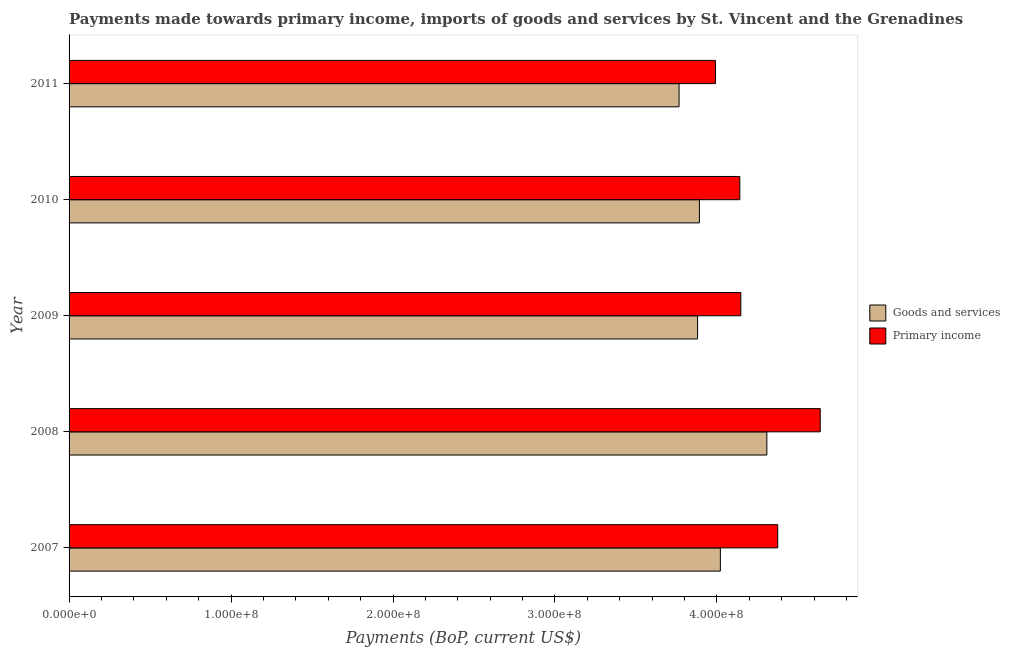How many different coloured bars are there?
Your response must be concise. 2. How many groups of bars are there?
Give a very brief answer. 5. Are the number of bars on each tick of the Y-axis equal?
Offer a very short reply. Yes. How many bars are there on the 5th tick from the top?
Make the answer very short. 2. How many bars are there on the 1st tick from the bottom?
Offer a very short reply. 2. What is the payments made towards goods and services in 2011?
Ensure brevity in your answer.  3.77e+08. Across all years, what is the maximum payments made towards primary income?
Your answer should be compact. 4.64e+08. Across all years, what is the minimum payments made towards primary income?
Your response must be concise. 3.99e+08. In which year was the payments made towards primary income maximum?
Give a very brief answer. 2008. In which year was the payments made towards primary income minimum?
Ensure brevity in your answer.  2011. What is the total payments made towards goods and services in the graph?
Your answer should be very brief. 1.99e+09. What is the difference between the payments made towards primary income in 2007 and that in 2008?
Your answer should be compact. -2.62e+07. What is the difference between the payments made towards primary income in 2011 and the payments made towards goods and services in 2007?
Give a very brief answer. -3.03e+06. What is the average payments made towards goods and services per year?
Your answer should be compact. 3.97e+08. In the year 2011, what is the difference between the payments made towards primary income and payments made towards goods and services?
Your response must be concise. 2.25e+07. What is the ratio of the payments made towards primary income in 2008 to that in 2010?
Offer a terse response. 1.12. What is the difference between the highest and the second highest payments made towards primary income?
Your answer should be very brief. 2.62e+07. What is the difference between the highest and the lowest payments made towards primary income?
Offer a terse response. 6.47e+07. In how many years, is the payments made towards primary income greater than the average payments made towards primary income taken over all years?
Give a very brief answer. 2. Is the sum of the payments made towards primary income in 2007 and 2009 greater than the maximum payments made towards goods and services across all years?
Your answer should be compact. Yes. What does the 1st bar from the top in 2007 represents?
Your answer should be very brief. Primary income. What does the 1st bar from the bottom in 2010 represents?
Offer a very short reply. Goods and services. Are all the bars in the graph horizontal?
Keep it short and to the point. Yes. Does the graph contain grids?
Keep it short and to the point. No. Where does the legend appear in the graph?
Your answer should be very brief. Center right. How are the legend labels stacked?
Make the answer very short. Vertical. What is the title of the graph?
Your response must be concise. Payments made towards primary income, imports of goods and services by St. Vincent and the Grenadines. What is the label or title of the X-axis?
Ensure brevity in your answer.  Payments (BoP, current US$). What is the Payments (BoP, current US$) of Goods and services in 2007?
Give a very brief answer. 4.02e+08. What is the Payments (BoP, current US$) in Primary income in 2007?
Keep it short and to the point. 4.38e+08. What is the Payments (BoP, current US$) of Goods and services in 2008?
Provide a succinct answer. 4.31e+08. What is the Payments (BoP, current US$) in Primary income in 2008?
Ensure brevity in your answer.  4.64e+08. What is the Payments (BoP, current US$) of Goods and services in 2009?
Offer a terse response. 3.88e+08. What is the Payments (BoP, current US$) in Primary income in 2009?
Offer a very short reply. 4.15e+08. What is the Payments (BoP, current US$) in Goods and services in 2010?
Give a very brief answer. 3.89e+08. What is the Payments (BoP, current US$) in Primary income in 2010?
Your response must be concise. 4.14e+08. What is the Payments (BoP, current US$) of Goods and services in 2011?
Provide a short and direct response. 3.77e+08. What is the Payments (BoP, current US$) in Primary income in 2011?
Your response must be concise. 3.99e+08. Across all years, what is the maximum Payments (BoP, current US$) of Goods and services?
Your response must be concise. 4.31e+08. Across all years, what is the maximum Payments (BoP, current US$) in Primary income?
Give a very brief answer. 4.64e+08. Across all years, what is the minimum Payments (BoP, current US$) in Goods and services?
Your answer should be very brief. 3.77e+08. Across all years, what is the minimum Payments (BoP, current US$) in Primary income?
Your answer should be compact. 3.99e+08. What is the total Payments (BoP, current US$) of Goods and services in the graph?
Your response must be concise. 1.99e+09. What is the total Payments (BoP, current US$) of Primary income in the graph?
Your answer should be compact. 2.13e+09. What is the difference between the Payments (BoP, current US$) of Goods and services in 2007 and that in 2008?
Give a very brief answer. -2.87e+07. What is the difference between the Payments (BoP, current US$) of Primary income in 2007 and that in 2008?
Keep it short and to the point. -2.62e+07. What is the difference between the Payments (BoP, current US$) of Goods and services in 2007 and that in 2009?
Ensure brevity in your answer.  1.41e+07. What is the difference between the Payments (BoP, current US$) of Primary income in 2007 and that in 2009?
Keep it short and to the point. 2.28e+07. What is the difference between the Payments (BoP, current US$) of Goods and services in 2007 and that in 2010?
Give a very brief answer. 1.29e+07. What is the difference between the Payments (BoP, current US$) in Primary income in 2007 and that in 2010?
Offer a terse response. 2.34e+07. What is the difference between the Payments (BoP, current US$) of Goods and services in 2007 and that in 2011?
Provide a short and direct response. 2.55e+07. What is the difference between the Payments (BoP, current US$) of Primary income in 2007 and that in 2011?
Provide a short and direct response. 3.84e+07. What is the difference between the Payments (BoP, current US$) in Goods and services in 2008 and that in 2009?
Offer a very short reply. 4.28e+07. What is the difference between the Payments (BoP, current US$) of Primary income in 2008 and that in 2009?
Your response must be concise. 4.90e+07. What is the difference between the Payments (BoP, current US$) of Goods and services in 2008 and that in 2010?
Keep it short and to the point. 4.16e+07. What is the difference between the Payments (BoP, current US$) in Primary income in 2008 and that in 2010?
Your response must be concise. 4.96e+07. What is the difference between the Payments (BoP, current US$) in Goods and services in 2008 and that in 2011?
Provide a short and direct response. 5.42e+07. What is the difference between the Payments (BoP, current US$) of Primary income in 2008 and that in 2011?
Provide a succinct answer. 6.47e+07. What is the difference between the Payments (BoP, current US$) in Goods and services in 2009 and that in 2010?
Offer a terse response. -1.13e+06. What is the difference between the Payments (BoP, current US$) in Primary income in 2009 and that in 2010?
Ensure brevity in your answer.  6.12e+05. What is the difference between the Payments (BoP, current US$) in Goods and services in 2009 and that in 2011?
Make the answer very short. 1.14e+07. What is the difference between the Payments (BoP, current US$) in Primary income in 2009 and that in 2011?
Provide a succinct answer. 1.56e+07. What is the difference between the Payments (BoP, current US$) in Goods and services in 2010 and that in 2011?
Ensure brevity in your answer.  1.26e+07. What is the difference between the Payments (BoP, current US$) in Primary income in 2010 and that in 2011?
Give a very brief answer. 1.50e+07. What is the difference between the Payments (BoP, current US$) of Goods and services in 2007 and the Payments (BoP, current US$) of Primary income in 2008?
Your response must be concise. -6.17e+07. What is the difference between the Payments (BoP, current US$) in Goods and services in 2007 and the Payments (BoP, current US$) in Primary income in 2009?
Your answer should be compact. -1.26e+07. What is the difference between the Payments (BoP, current US$) of Goods and services in 2007 and the Payments (BoP, current US$) of Primary income in 2010?
Provide a short and direct response. -1.20e+07. What is the difference between the Payments (BoP, current US$) in Goods and services in 2007 and the Payments (BoP, current US$) in Primary income in 2011?
Make the answer very short. 3.03e+06. What is the difference between the Payments (BoP, current US$) in Goods and services in 2008 and the Payments (BoP, current US$) in Primary income in 2009?
Offer a terse response. 1.61e+07. What is the difference between the Payments (BoP, current US$) of Goods and services in 2008 and the Payments (BoP, current US$) of Primary income in 2010?
Ensure brevity in your answer.  1.67e+07. What is the difference between the Payments (BoP, current US$) in Goods and services in 2008 and the Payments (BoP, current US$) in Primary income in 2011?
Ensure brevity in your answer.  3.17e+07. What is the difference between the Payments (BoP, current US$) of Goods and services in 2009 and the Payments (BoP, current US$) of Primary income in 2010?
Offer a terse response. -2.61e+07. What is the difference between the Payments (BoP, current US$) of Goods and services in 2009 and the Payments (BoP, current US$) of Primary income in 2011?
Make the answer very short. -1.10e+07. What is the difference between the Payments (BoP, current US$) of Goods and services in 2010 and the Payments (BoP, current US$) of Primary income in 2011?
Your answer should be very brief. -9.91e+06. What is the average Payments (BoP, current US$) of Goods and services per year?
Give a very brief answer. 3.97e+08. What is the average Payments (BoP, current US$) in Primary income per year?
Offer a terse response. 4.26e+08. In the year 2007, what is the difference between the Payments (BoP, current US$) of Goods and services and Payments (BoP, current US$) of Primary income?
Ensure brevity in your answer.  -3.54e+07. In the year 2008, what is the difference between the Payments (BoP, current US$) in Goods and services and Payments (BoP, current US$) in Primary income?
Provide a short and direct response. -3.30e+07. In the year 2009, what is the difference between the Payments (BoP, current US$) in Goods and services and Payments (BoP, current US$) in Primary income?
Make the answer very short. -2.67e+07. In the year 2010, what is the difference between the Payments (BoP, current US$) in Goods and services and Payments (BoP, current US$) in Primary income?
Your response must be concise. -2.49e+07. In the year 2011, what is the difference between the Payments (BoP, current US$) in Goods and services and Payments (BoP, current US$) in Primary income?
Provide a succinct answer. -2.25e+07. What is the ratio of the Payments (BoP, current US$) of Goods and services in 2007 to that in 2008?
Provide a short and direct response. 0.93. What is the ratio of the Payments (BoP, current US$) in Primary income in 2007 to that in 2008?
Provide a short and direct response. 0.94. What is the ratio of the Payments (BoP, current US$) in Goods and services in 2007 to that in 2009?
Keep it short and to the point. 1.04. What is the ratio of the Payments (BoP, current US$) in Primary income in 2007 to that in 2009?
Give a very brief answer. 1.05. What is the ratio of the Payments (BoP, current US$) of Goods and services in 2007 to that in 2010?
Ensure brevity in your answer.  1.03. What is the ratio of the Payments (BoP, current US$) in Primary income in 2007 to that in 2010?
Your answer should be compact. 1.06. What is the ratio of the Payments (BoP, current US$) in Goods and services in 2007 to that in 2011?
Provide a succinct answer. 1.07. What is the ratio of the Payments (BoP, current US$) of Primary income in 2007 to that in 2011?
Your response must be concise. 1.1. What is the ratio of the Payments (BoP, current US$) of Goods and services in 2008 to that in 2009?
Keep it short and to the point. 1.11. What is the ratio of the Payments (BoP, current US$) of Primary income in 2008 to that in 2009?
Your response must be concise. 1.12. What is the ratio of the Payments (BoP, current US$) in Goods and services in 2008 to that in 2010?
Ensure brevity in your answer.  1.11. What is the ratio of the Payments (BoP, current US$) of Primary income in 2008 to that in 2010?
Provide a short and direct response. 1.12. What is the ratio of the Payments (BoP, current US$) in Goods and services in 2008 to that in 2011?
Ensure brevity in your answer.  1.14. What is the ratio of the Payments (BoP, current US$) of Primary income in 2008 to that in 2011?
Make the answer very short. 1.16. What is the ratio of the Payments (BoP, current US$) of Primary income in 2009 to that in 2010?
Provide a short and direct response. 1. What is the ratio of the Payments (BoP, current US$) of Goods and services in 2009 to that in 2011?
Give a very brief answer. 1.03. What is the ratio of the Payments (BoP, current US$) of Primary income in 2009 to that in 2011?
Give a very brief answer. 1.04. What is the ratio of the Payments (BoP, current US$) of Goods and services in 2010 to that in 2011?
Provide a succinct answer. 1.03. What is the ratio of the Payments (BoP, current US$) in Primary income in 2010 to that in 2011?
Provide a succinct answer. 1.04. What is the difference between the highest and the second highest Payments (BoP, current US$) in Goods and services?
Provide a short and direct response. 2.87e+07. What is the difference between the highest and the second highest Payments (BoP, current US$) of Primary income?
Ensure brevity in your answer.  2.62e+07. What is the difference between the highest and the lowest Payments (BoP, current US$) in Goods and services?
Your response must be concise. 5.42e+07. What is the difference between the highest and the lowest Payments (BoP, current US$) in Primary income?
Keep it short and to the point. 6.47e+07. 